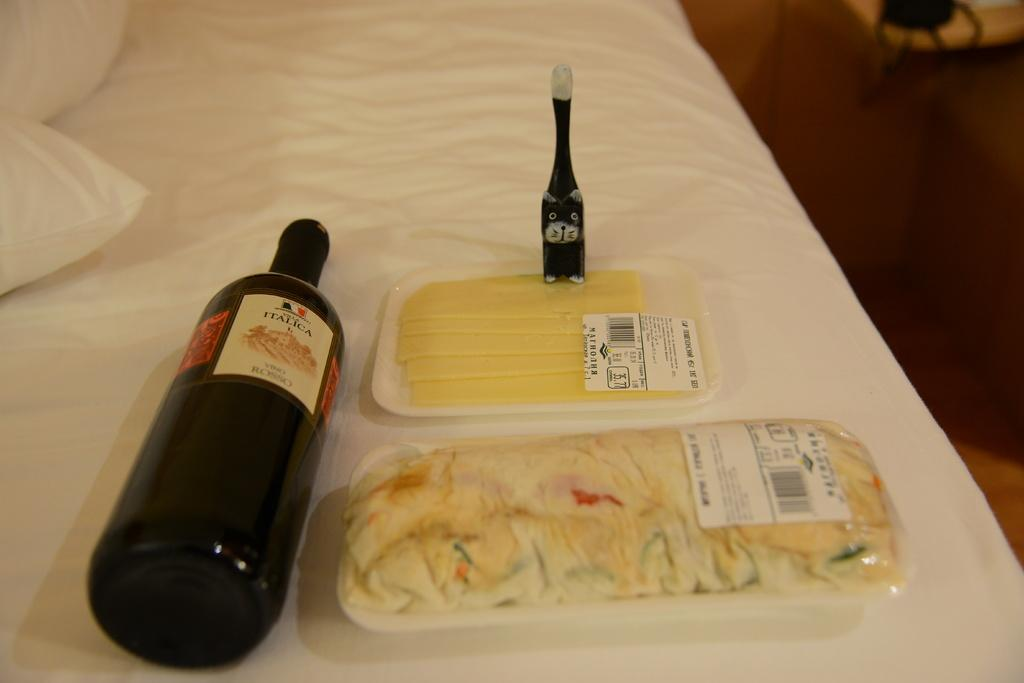Provide a one-sentence caption for the provided image. A bottle of Italica sits on it's side on a table. 